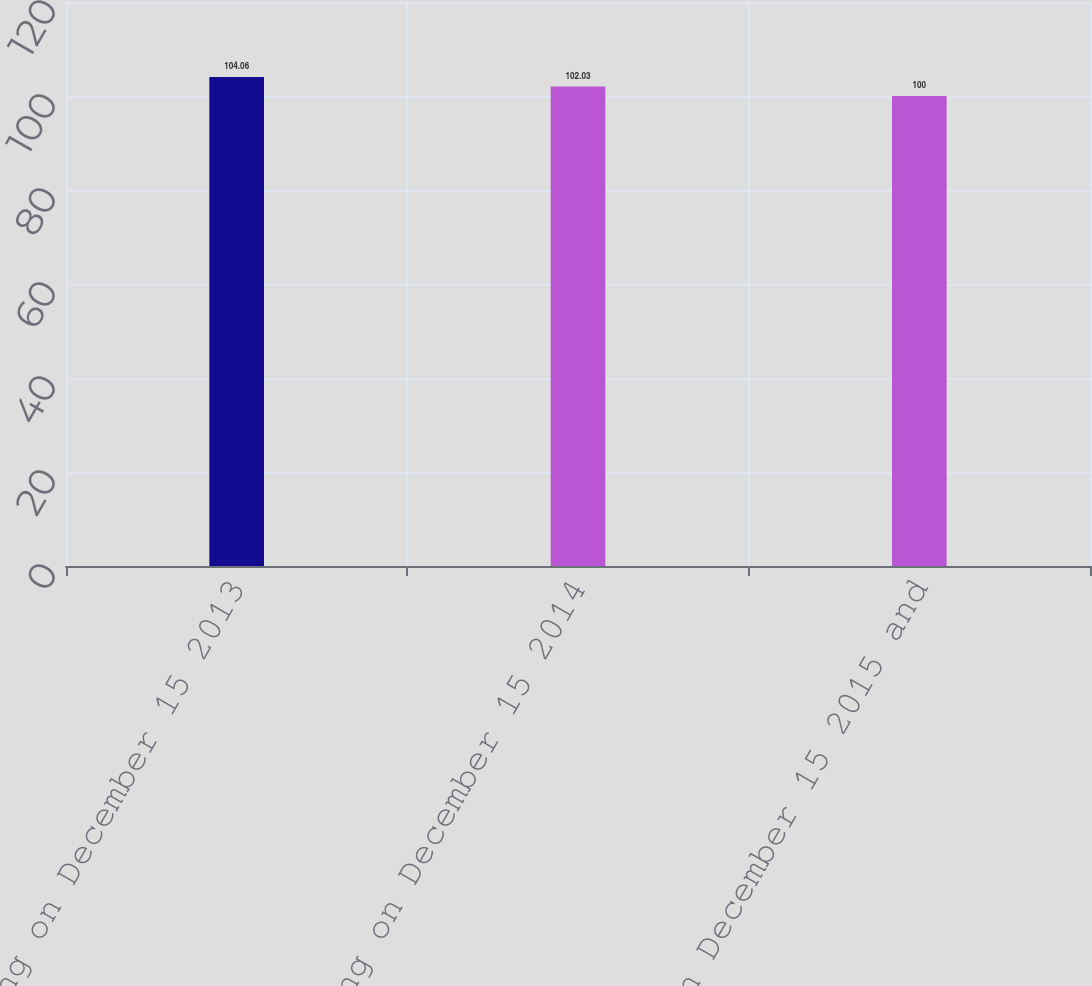<chart> <loc_0><loc_0><loc_500><loc_500><bar_chart><fcel>Beginning on December 15 2013<fcel>Beginning on December 15 2014<fcel>On December 15 2015 and<nl><fcel>104.06<fcel>102.03<fcel>100<nl></chart> 